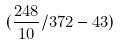<formula> <loc_0><loc_0><loc_500><loc_500>( \frac { 2 4 8 } { 1 0 } / 3 7 2 - 4 3 )</formula> 